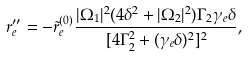<formula> <loc_0><loc_0><loc_500><loc_500>r _ { e } ^ { \prime \prime } = - \tilde { r } _ { e } ^ { ( 0 ) } \frac { | \Omega _ { 1 } | ^ { 2 } ( 4 \delta ^ { 2 } + | \Omega _ { 2 } | ^ { 2 } ) \Gamma _ { 2 } \gamma _ { e } \delta } { [ 4 \Gamma _ { 2 } ^ { 2 } + ( \gamma _ { e } \delta ) ^ { 2 } ] ^ { 2 } } ,</formula> 